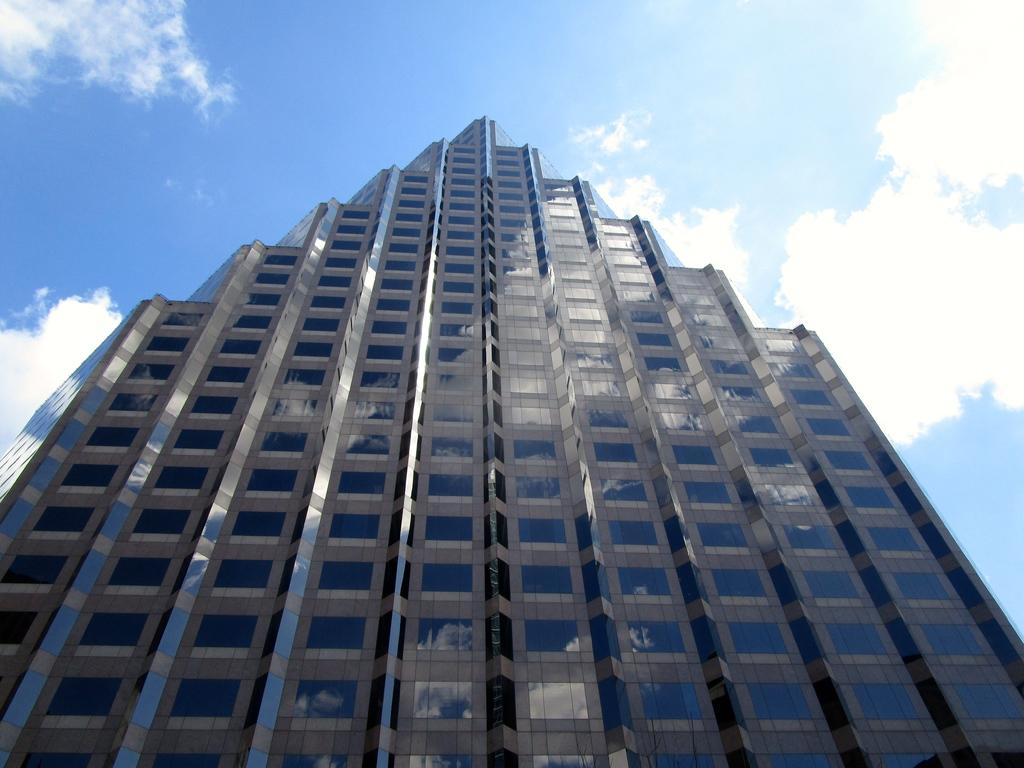What type of building is depicted in the image? There is a glass building in the image. What can be seen in the background of the image? The sky is visible in the background of the image. How would you describe the weather based on the appearance of the sky? The sky appears to be cloudy, which might suggest overcast or potentially rainy weather. What type of toothbrush is being used to clean the windows of the building in the image? There is no toothbrush visible in the image, and the windows of the building are not being cleaned. 